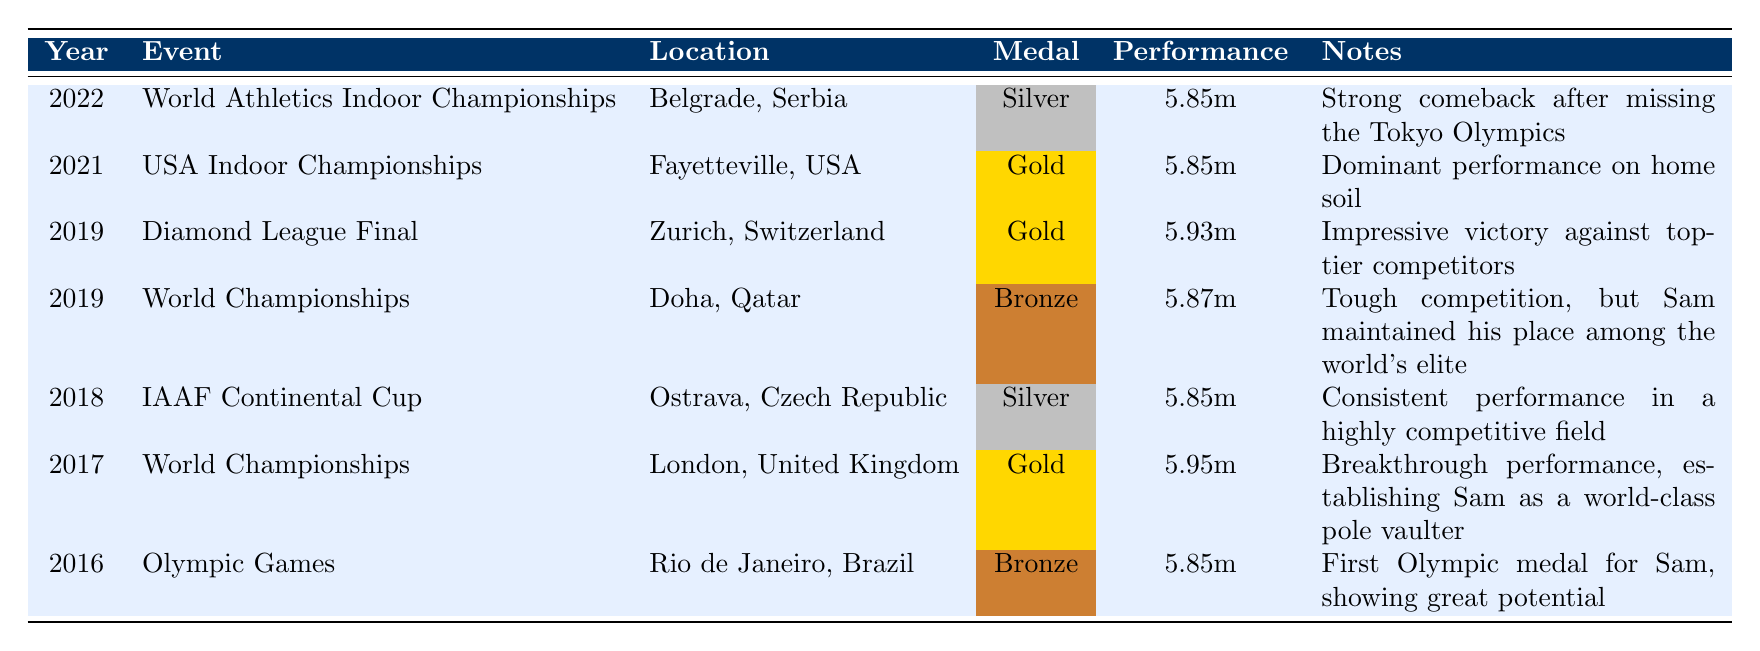What medal did Sam Kendricks win at the 2016 Olympic Games? In the table, it is specified that the medal Sam Kendricks won in 2016 at the Olympic Games is Bronze.
Answer: Bronze In which year did Sam Kendricks achieve his best performance of 5.95m? According to the table, the performance of 5.95m is listed under the World Championships in 2017.
Answer: 2017 How many Gold medals did Sam Kendricks win at international competitions in 2019? The table shows that in 2019, Sam Kendricks won a Gold medal at the Diamond League Final and another Gold medal at the USA Indoor Championships, totaling two Gold medals.
Answer: 2 What was the performance height that earned Sam Kendricks a Silver medal in the 2022 World Athletics Indoor Championships? The table states that Sam Kendricks achieved a performance of 5.85m to win the Silver medal in 2022 at the World Athletics Indoor Championships.
Answer: 5.85m Did Sam Kendricks win a medal at the 2018 IAAF Continental Cup? Yes, the table indicates that he won a Silver medal at the IAAF Continental Cup in 2018.
Answer: Yes Which event did Sam Kendricks compete in before the 2021 USA Indoor Championships? The table reveals that the last event before the USA Indoor Championships in 2021 was the World Championships in 2019, as there are no events listed in 2020 due to the pandemic.
Answer: World Championships What was Sam Kendricks' average performance height for his medals in 2016 and 2017? For 2016 and 2017, the performance heights are 5.85m (Bronze in 2016) and 5.95m (Gold in 2017). To find the average, we sum them up: 5.85 + 5.95 = 11.80 and divide by 2: 11.80 / 2 = 5.90.
Answer: 5.90 Which event had the highest performance height by Sam Kendricks, and what was that height? The table indicates that his highest performance height was 5.95m at the World Championships in 2017.
Answer: 5.95m How many medals did Sam Kendricks win in 2019? The table lists two events for 2019, with Sam winning a Bronze medal at the World Championships and a Gold medal at the Diamond League Final, totaling two medals.
Answer: 2 